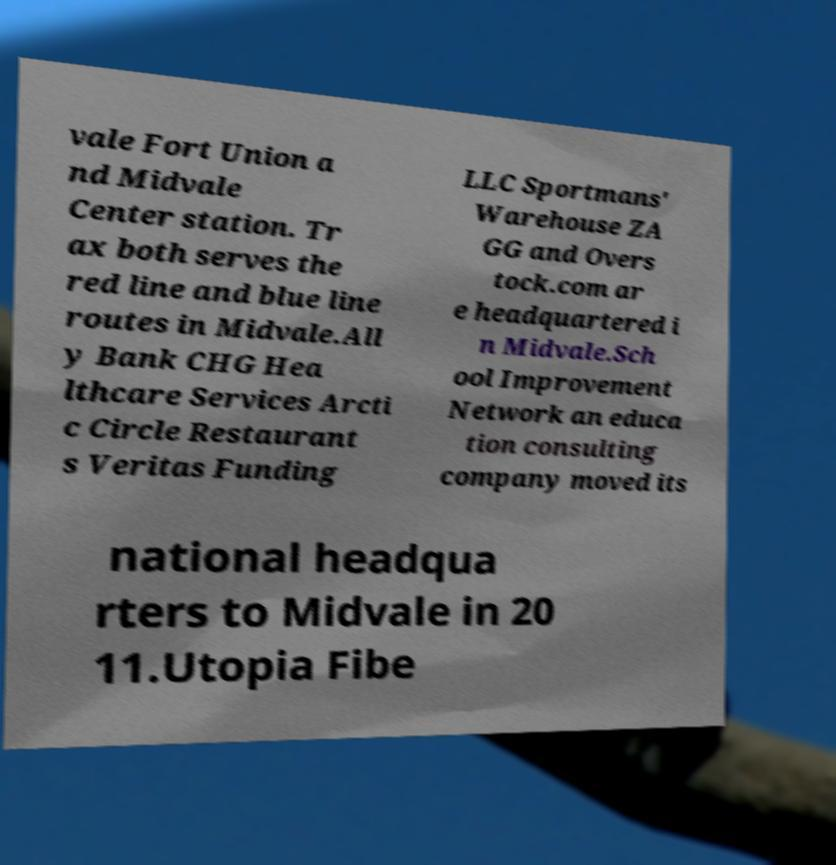Can you read and provide the text displayed in the image?This photo seems to have some interesting text. Can you extract and type it out for me? vale Fort Union a nd Midvale Center station. Tr ax both serves the red line and blue line routes in Midvale.All y Bank CHG Hea lthcare Services Arcti c Circle Restaurant s Veritas Funding LLC Sportmans' Warehouse ZA GG and Overs tock.com ar e headquartered i n Midvale.Sch ool Improvement Network an educa tion consulting company moved its national headqua rters to Midvale in 20 11.Utopia Fibe 